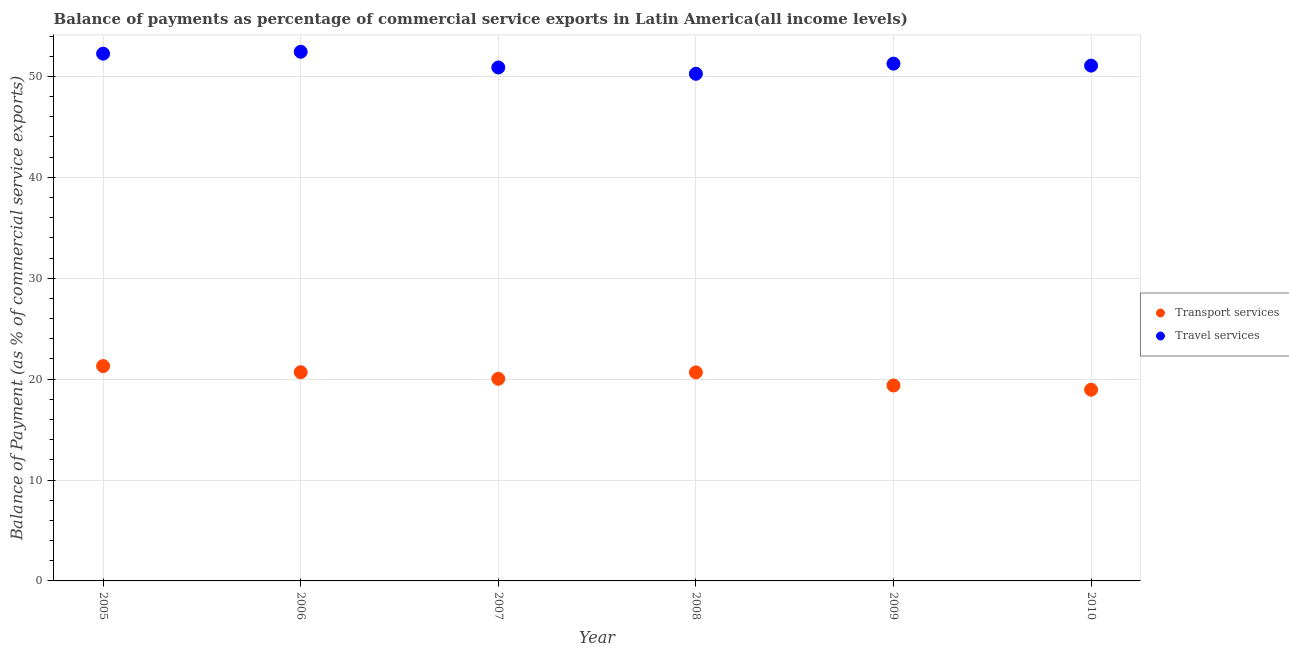What is the balance of payments of travel services in 2005?
Provide a succinct answer. 52.25. Across all years, what is the maximum balance of payments of travel services?
Make the answer very short. 52.44. Across all years, what is the minimum balance of payments of transport services?
Your answer should be very brief. 18.95. In which year was the balance of payments of transport services maximum?
Ensure brevity in your answer.  2005. What is the total balance of payments of travel services in the graph?
Provide a short and direct response. 308.18. What is the difference between the balance of payments of travel services in 2007 and that in 2010?
Your answer should be very brief. -0.18. What is the difference between the balance of payments of transport services in 2006 and the balance of payments of travel services in 2005?
Give a very brief answer. -31.57. What is the average balance of payments of transport services per year?
Keep it short and to the point. 20.17. In the year 2007, what is the difference between the balance of payments of transport services and balance of payments of travel services?
Offer a very short reply. -30.85. In how many years, is the balance of payments of travel services greater than 16 %?
Provide a succinct answer. 6. What is the ratio of the balance of payments of transport services in 2005 to that in 2008?
Your response must be concise. 1.03. Is the balance of payments of travel services in 2009 less than that in 2010?
Provide a short and direct response. No. What is the difference between the highest and the second highest balance of payments of transport services?
Your response must be concise. 0.61. What is the difference between the highest and the lowest balance of payments of travel services?
Provide a succinct answer. 2.18. In how many years, is the balance of payments of travel services greater than the average balance of payments of travel services taken over all years?
Your answer should be compact. 2. Is the balance of payments of travel services strictly less than the balance of payments of transport services over the years?
Provide a short and direct response. No. How many dotlines are there?
Your answer should be compact. 2. What is the difference between two consecutive major ticks on the Y-axis?
Give a very brief answer. 10. How many legend labels are there?
Your answer should be very brief. 2. How are the legend labels stacked?
Keep it short and to the point. Vertical. What is the title of the graph?
Give a very brief answer. Balance of payments as percentage of commercial service exports in Latin America(all income levels). What is the label or title of the Y-axis?
Offer a very short reply. Balance of Payment (as % of commercial service exports). What is the Balance of Payment (as % of commercial service exports) of Transport services in 2005?
Ensure brevity in your answer.  21.29. What is the Balance of Payment (as % of commercial service exports) of Travel services in 2005?
Provide a short and direct response. 52.25. What is the Balance of Payment (as % of commercial service exports) in Transport services in 2006?
Your answer should be compact. 20.68. What is the Balance of Payment (as % of commercial service exports) in Travel services in 2006?
Your answer should be very brief. 52.44. What is the Balance of Payment (as % of commercial service exports) of Transport services in 2007?
Provide a short and direct response. 20.03. What is the Balance of Payment (as % of commercial service exports) of Travel services in 2007?
Keep it short and to the point. 50.89. What is the Balance of Payment (as % of commercial service exports) in Transport services in 2008?
Offer a terse response. 20.67. What is the Balance of Payment (as % of commercial service exports) of Travel services in 2008?
Provide a succinct answer. 50.26. What is the Balance of Payment (as % of commercial service exports) in Transport services in 2009?
Offer a very short reply. 19.37. What is the Balance of Payment (as % of commercial service exports) of Travel services in 2009?
Make the answer very short. 51.26. What is the Balance of Payment (as % of commercial service exports) of Transport services in 2010?
Your answer should be compact. 18.95. What is the Balance of Payment (as % of commercial service exports) in Travel services in 2010?
Keep it short and to the point. 51.07. Across all years, what is the maximum Balance of Payment (as % of commercial service exports) of Transport services?
Your answer should be compact. 21.29. Across all years, what is the maximum Balance of Payment (as % of commercial service exports) of Travel services?
Make the answer very short. 52.44. Across all years, what is the minimum Balance of Payment (as % of commercial service exports) of Transport services?
Provide a succinct answer. 18.95. Across all years, what is the minimum Balance of Payment (as % of commercial service exports) in Travel services?
Your answer should be very brief. 50.26. What is the total Balance of Payment (as % of commercial service exports) in Transport services in the graph?
Offer a very short reply. 121. What is the total Balance of Payment (as % of commercial service exports) in Travel services in the graph?
Provide a succinct answer. 308.18. What is the difference between the Balance of Payment (as % of commercial service exports) in Transport services in 2005 and that in 2006?
Make the answer very short. 0.61. What is the difference between the Balance of Payment (as % of commercial service exports) in Travel services in 2005 and that in 2006?
Provide a succinct answer. -0.19. What is the difference between the Balance of Payment (as % of commercial service exports) in Transport services in 2005 and that in 2007?
Ensure brevity in your answer.  1.26. What is the difference between the Balance of Payment (as % of commercial service exports) in Travel services in 2005 and that in 2007?
Give a very brief answer. 1.37. What is the difference between the Balance of Payment (as % of commercial service exports) in Transport services in 2005 and that in 2008?
Your response must be concise. 0.63. What is the difference between the Balance of Payment (as % of commercial service exports) of Travel services in 2005 and that in 2008?
Provide a succinct answer. 1.99. What is the difference between the Balance of Payment (as % of commercial service exports) of Transport services in 2005 and that in 2009?
Offer a terse response. 1.93. What is the difference between the Balance of Payment (as % of commercial service exports) of Transport services in 2005 and that in 2010?
Offer a terse response. 2.34. What is the difference between the Balance of Payment (as % of commercial service exports) of Travel services in 2005 and that in 2010?
Offer a very short reply. 1.18. What is the difference between the Balance of Payment (as % of commercial service exports) of Transport services in 2006 and that in 2007?
Provide a short and direct response. 0.65. What is the difference between the Balance of Payment (as % of commercial service exports) of Travel services in 2006 and that in 2007?
Ensure brevity in your answer.  1.56. What is the difference between the Balance of Payment (as % of commercial service exports) in Transport services in 2006 and that in 2008?
Provide a succinct answer. 0.02. What is the difference between the Balance of Payment (as % of commercial service exports) of Travel services in 2006 and that in 2008?
Provide a short and direct response. 2.18. What is the difference between the Balance of Payment (as % of commercial service exports) of Transport services in 2006 and that in 2009?
Your response must be concise. 1.32. What is the difference between the Balance of Payment (as % of commercial service exports) of Travel services in 2006 and that in 2009?
Offer a terse response. 1.18. What is the difference between the Balance of Payment (as % of commercial service exports) of Transport services in 2006 and that in 2010?
Give a very brief answer. 1.73. What is the difference between the Balance of Payment (as % of commercial service exports) of Travel services in 2006 and that in 2010?
Your answer should be very brief. 1.37. What is the difference between the Balance of Payment (as % of commercial service exports) of Transport services in 2007 and that in 2008?
Offer a very short reply. -0.63. What is the difference between the Balance of Payment (as % of commercial service exports) in Travel services in 2007 and that in 2008?
Make the answer very short. 0.63. What is the difference between the Balance of Payment (as % of commercial service exports) in Transport services in 2007 and that in 2009?
Your answer should be very brief. 0.66. What is the difference between the Balance of Payment (as % of commercial service exports) of Travel services in 2007 and that in 2009?
Keep it short and to the point. -0.38. What is the difference between the Balance of Payment (as % of commercial service exports) of Transport services in 2007 and that in 2010?
Give a very brief answer. 1.08. What is the difference between the Balance of Payment (as % of commercial service exports) of Travel services in 2007 and that in 2010?
Offer a terse response. -0.18. What is the difference between the Balance of Payment (as % of commercial service exports) of Transport services in 2008 and that in 2009?
Keep it short and to the point. 1.3. What is the difference between the Balance of Payment (as % of commercial service exports) in Travel services in 2008 and that in 2009?
Offer a terse response. -1. What is the difference between the Balance of Payment (as % of commercial service exports) of Transport services in 2008 and that in 2010?
Make the answer very short. 1.71. What is the difference between the Balance of Payment (as % of commercial service exports) of Travel services in 2008 and that in 2010?
Give a very brief answer. -0.81. What is the difference between the Balance of Payment (as % of commercial service exports) in Transport services in 2009 and that in 2010?
Your answer should be compact. 0.42. What is the difference between the Balance of Payment (as % of commercial service exports) of Travel services in 2009 and that in 2010?
Your response must be concise. 0.2. What is the difference between the Balance of Payment (as % of commercial service exports) in Transport services in 2005 and the Balance of Payment (as % of commercial service exports) in Travel services in 2006?
Provide a succinct answer. -31.15. What is the difference between the Balance of Payment (as % of commercial service exports) in Transport services in 2005 and the Balance of Payment (as % of commercial service exports) in Travel services in 2007?
Your answer should be very brief. -29.59. What is the difference between the Balance of Payment (as % of commercial service exports) in Transport services in 2005 and the Balance of Payment (as % of commercial service exports) in Travel services in 2008?
Ensure brevity in your answer.  -28.97. What is the difference between the Balance of Payment (as % of commercial service exports) in Transport services in 2005 and the Balance of Payment (as % of commercial service exports) in Travel services in 2009?
Offer a terse response. -29.97. What is the difference between the Balance of Payment (as % of commercial service exports) in Transport services in 2005 and the Balance of Payment (as % of commercial service exports) in Travel services in 2010?
Offer a terse response. -29.77. What is the difference between the Balance of Payment (as % of commercial service exports) of Transport services in 2006 and the Balance of Payment (as % of commercial service exports) of Travel services in 2007?
Provide a short and direct response. -30.2. What is the difference between the Balance of Payment (as % of commercial service exports) in Transport services in 2006 and the Balance of Payment (as % of commercial service exports) in Travel services in 2008?
Offer a very short reply. -29.58. What is the difference between the Balance of Payment (as % of commercial service exports) of Transport services in 2006 and the Balance of Payment (as % of commercial service exports) of Travel services in 2009?
Your response must be concise. -30.58. What is the difference between the Balance of Payment (as % of commercial service exports) of Transport services in 2006 and the Balance of Payment (as % of commercial service exports) of Travel services in 2010?
Your response must be concise. -30.39. What is the difference between the Balance of Payment (as % of commercial service exports) in Transport services in 2007 and the Balance of Payment (as % of commercial service exports) in Travel services in 2008?
Your response must be concise. -30.23. What is the difference between the Balance of Payment (as % of commercial service exports) in Transport services in 2007 and the Balance of Payment (as % of commercial service exports) in Travel services in 2009?
Provide a succinct answer. -31.23. What is the difference between the Balance of Payment (as % of commercial service exports) of Transport services in 2007 and the Balance of Payment (as % of commercial service exports) of Travel services in 2010?
Ensure brevity in your answer.  -31.04. What is the difference between the Balance of Payment (as % of commercial service exports) in Transport services in 2008 and the Balance of Payment (as % of commercial service exports) in Travel services in 2009?
Offer a terse response. -30.6. What is the difference between the Balance of Payment (as % of commercial service exports) of Transport services in 2008 and the Balance of Payment (as % of commercial service exports) of Travel services in 2010?
Your answer should be very brief. -30.4. What is the difference between the Balance of Payment (as % of commercial service exports) in Transport services in 2009 and the Balance of Payment (as % of commercial service exports) in Travel services in 2010?
Provide a succinct answer. -31.7. What is the average Balance of Payment (as % of commercial service exports) of Transport services per year?
Give a very brief answer. 20.17. What is the average Balance of Payment (as % of commercial service exports) of Travel services per year?
Make the answer very short. 51.36. In the year 2005, what is the difference between the Balance of Payment (as % of commercial service exports) in Transport services and Balance of Payment (as % of commercial service exports) in Travel services?
Provide a succinct answer. -30.96. In the year 2006, what is the difference between the Balance of Payment (as % of commercial service exports) in Transport services and Balance of Payment (as % of commercial service exports) in Travel services?
Provide a short and direct response. -31.76. In the year 2007, what is the difference between the Balance of Payment (as % of commercial service exports) in Transport services and Balance of Payment (as % of commercial service exports) in Travel services?
Offer a terse response. -30.85. In the year 2008, what is the difference between the Balance of Payment (as % of commercial service exports) in Transport services and Balance of Payment (as % of commercial service exports) in Travel services?
Make the answer very short. -29.59. In the year 2009, what is the difference between the Balance of Payment (as % of commercial service exports) in Transport services and Balance of Payment (as % of commercial service exports) in Travel services?
Keep it short and to the point. -31.9. In the year 2010, what is the difference between the Balance of Payment (as % of commercial service exports) of Transport services and Balance of Payment (as % of commercial service exports) of Travel services?
Keep it short and to the point. -32.12. What is the ratio of the Balance of Payment (as % of commercial service exports) in Transport services in 2005 to that in 2006?
Keep it short and to the point. 1.03. What is the ratio of the Balance of Payment (as % of commercial service exports) of Travel services in 2005 to that in 2006?
Give a very brief answer. 1. What is the ratio of the Balance of Payment (as % of commercial service exports) of Transport services in 2005 to that in 2007?
Give a very brief answer. 1.06. What is the ratio of the Balance of Payment (as % of commercial service exports) of Travel services in 2005 to that in 2007?
Make the answer very short. 1.03. What is the ratio of the Balance of Payment (as % of commercial service exports) of Transport services in 2005 to that in 2008?
Your answer should be compact. 1.03. What is the ratio of the Balance of Payment (as % of commercial service exports) in Travel services in 2005 to that in 2008?
Provide a succinct answer. 1.04. What is the ratio of the Balance of Payment (as % of commercial service exports) in Transport services in 2005 to that in 2009?
Your answer should be very brief. 1.1. What is the ratio of the Balance of Payment (as % of commercial service exports) in Travel services in 2005 to that in 2009?
Make the answer very short. 1.02. What is the ratio of the Balance of Payment (as % of commercial service exports) in Transport services in 2005 to that in 2010?
Ensure brevity in your answer.  1.12. What is the ratio of the Balance of Payment (as % of commercial service exports) of Travel services in 2005 to that in 2010?
Provide a short and direct response. 1.02. What is the ratio of the Balance of Payment (as % of commercial service exports) of Transport services in 2006 to that in 2007?
Ensure brevity in your answer.  1.03. What is the ratio of the Balance of Payment (as % of commercial service exports) of Travel services in 2006 to that in 2007?
Offer a very short reply. 1.03. What is the ratio of the Balance of Payment (as % of commercial service exports) in Transport services in 2006 to that in 2008?
Your response must be concise. 1. What is the ratio of the Balance of Payment (as % of commercial service exports) in Travel services in 2006 to that in 2008?
Offer a very short reply. 1.04. What is the ratio of the Balance of Payment (as % of commercial service exports) in Transport services in 2006 to that in 2009?
Give a very brief answer. 1.07. What is the ratio of the Balance of Payment (as % of commercial service exports) of Transport services in 2006 to that in 2010?
Provide a short and direct response. 1.09. What is the ratio of the Balance of Payment (as % of commercial service exports) of Travel services in 2006 to that in 2010?
Your answer should be compact. 1.03. What is the ratio of the Balance of Payment (as % of commercial service exports) in Transport services in 2007 to that in 2008?
Give a very brief answer. 0.97. What is the ratio of the Balance of Payment (as % of commercial service exports) of Travel services in 2007 to that in 2008?
Give a very brief answer. 1.01. What is the ratio of the Balance of Payment (as % of commercial service exports) of Transport services in 2007 to that in 2009?
Your answer should be very brief. 1.03. What is the ratio of the Balance of Payment (as % of commercial service exports) in Transport services in 2007 to that in 2010?
Keep it short and to the point. 1.06. What is the ratio of the Balance of Payment (as % of commercial service exports) of Travel services in 2007 to that in 2010?
Offer a very short reply. 1. What is the ratio of the Balance of Payment (as % of commercial service exports) of Transport services in 2008 to that in 2009?
Ensure brevity in your answer.  1.07. What is the ratio of the Balance of Payment (as % of commercial service exports) in Travel services in 2008 to that in 2009?
Offer a very short reply. 0.98. What is the ratio of the Balance of Payment (as % of commercial service exports) of Transport services in 2008 to that in 2010?
Ensure brevity in your answer.  1.09. What is the ratio of the Balance of Payment (as % of commercial service exports) of Travel services in 2008 to that in 2010?
Your answer should be compact. 0.98. What is the ratio of the Balance of Payment (as % of commercial service exports) in Transport services in 2009 to that in 2010?
Offer a very short reply. 1.02. What is the difference between the highest and the second highest Balance of Payment (as % of commercial service exports) of Transport services?
Provide a succinct answer. 0.61. What is the difference between the highest and the second highest Balance of Payment (as % of commercial service exports) of Travel services?
Provide a succinct answer. 0.19. What is the difference between the highest and the lowest Balance of Payment (as % of commercial service exports) of Transport services?
Ensure brevity in your answer.  2.34. What is the difference between the highest and the lowest Balance of Payment (as % of commercial service exports) in Travel services?
Your response must be concise. 2.18. 